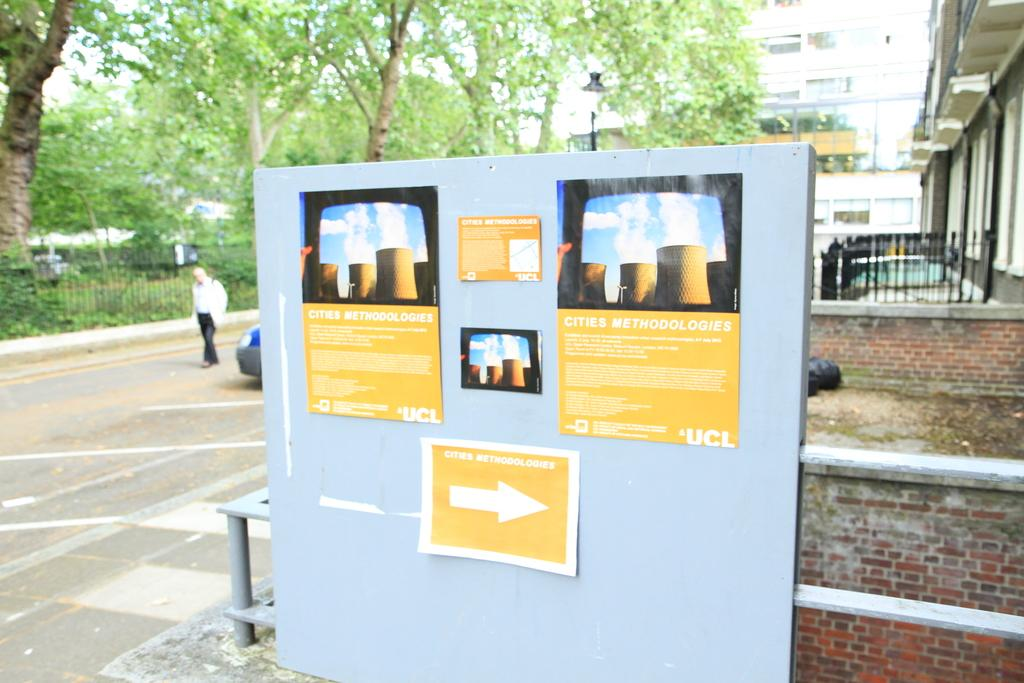What is located in the center of the image? There are posts to the wall in the center of the image. What can be seen in the background of the image? There are trees, fencing, a person, a car, a building, and the sky visible in the background of the image. What type of texture can be seen on the person's clothing in the image? There is no information about the person's clothing or texture in the image. 